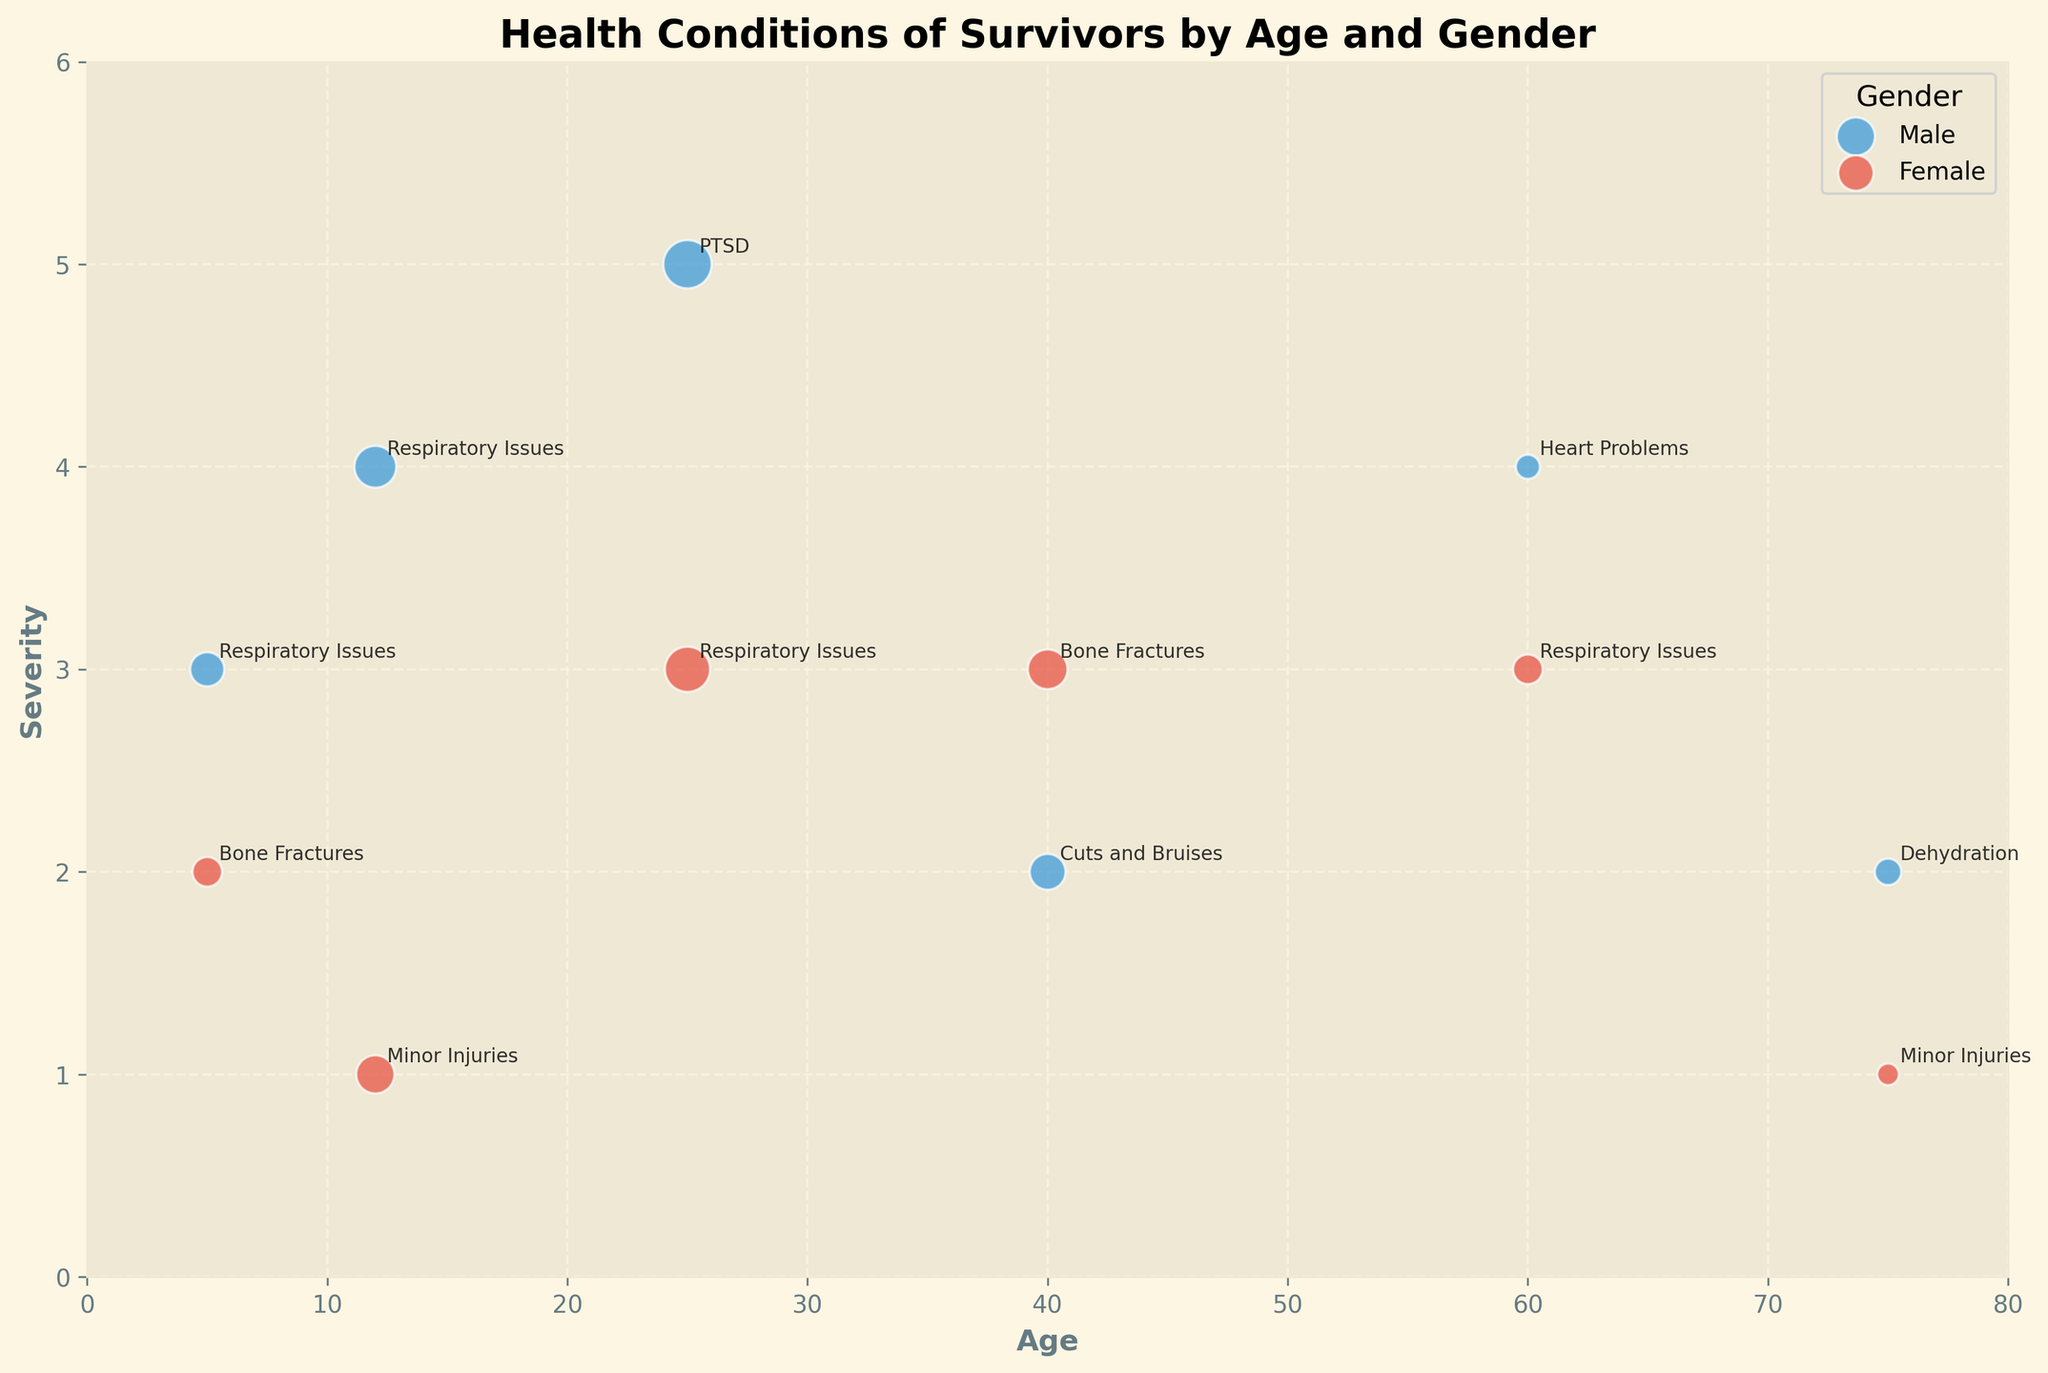what is the title of the plot? The title of the plot is usually found at the top and is labeled with larger and bold text. Here, the title at the top reads, 'Health Conditions of Survivors by Age and Gender'.
Answer: Health Conditions of Survivors by Age and Gender What are the axis labels? The axis labels provide context for each axis and are found directly next to the respective axis lines. The x-axis is labeled 'Age', and the y-axis is labeled 'Severity'.
Answer: Age (x-axis) and Severity (y-axis) How many different health conditions are depicted on the chart? By looking at the annotations on the plot, you can count the distinct health conditions. They are Respiratory Issues, Bone Fractures, Minor Injuries, PTSD, Cuts and Bruises, Heart Problems, and Dehydration.
Answer: 7 Which age group has the most survivors with respiratory issues? Examine the size of the bubbles annotated with 'Respiratory Issues'. The age groups are 5, 12, 25, and 60. The largest bubble appears at age 12 (Male, 30 survivors).
Answer: 12 (Male) For which health condition is the severity highest among females? Identify the health conditions associated with female survivors and note their severity levels. PTSD in the 25-year-old age group has the highest severity with a severity level of 5.
Answer: PTSD Which gender has a higher number of survivors with bone fractures aged 40? By comparing the sizes of the bubbles in the 40 age group related to Bone Fractures (Male: 22, Female: 27), the female bubble is larger.
Answer: Female What is the average severity level across all age groups for male survivors? Sum the severities from each male age group, then divide by the number of male data points: (3+4+5+2+4+2)/6 = 20/6 ≈ 3.33.
Answer: 3.33 At what age do male survivors experience heart problems, and how severe are they? Locate the bubble labeled 'Heart Problems' associated with males. This problem appears for the 60 age group with a severity level of 4.
Answer: 60 years old, Severity 4 Which age group has the smallest number of female survivors with minor injuries? Compare the sizes of the bubbles labeled 'Minor Injuries' associated with females. The smallest bubble is at age 75 with 8 survivors.
Answer: Age 75, 8 survivors 